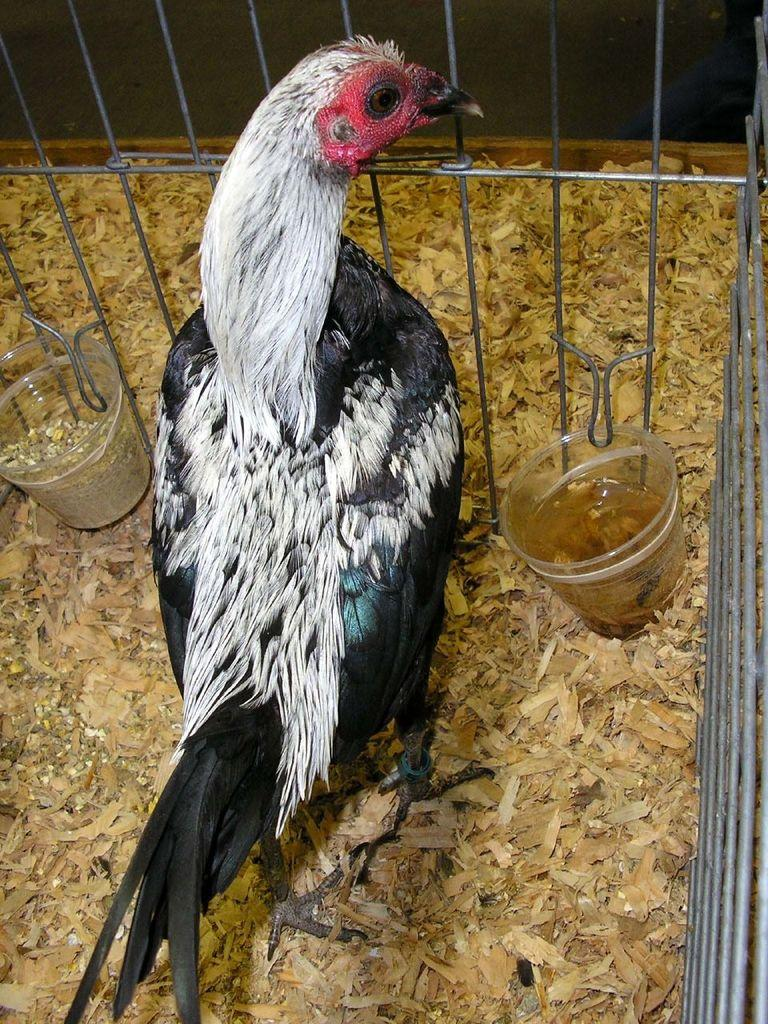What animal can be seen in the image? There is a hen in a cage in the image. What is in the glasses that are visible in the image? There are two glasses with water in the image, and grains are also present in the glasses. What can be found on the surface in the image? There are feathers and some objects on the surface in the image. How many feet can be seen in the image? There is no mention of feet in the image, as it primarily features a hen in a cage, glasses with water and grains, and objects on the surface. 